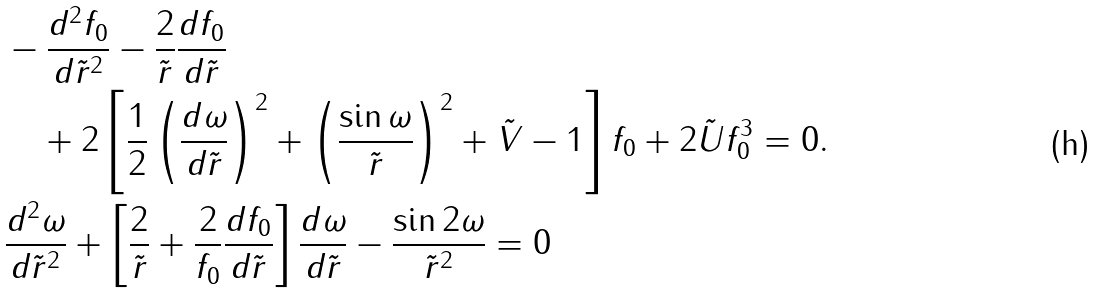<formula> <loc_0><loc_0><loc_500><loc_500>& - \frac { d ^ { 2 } f _ { 0 } } { d \tilde { r } ^ { 2 } } - \frac { 2 } { \tilde { r } } \frac { d f _ { 0 } } { d \tilde { r } } \\ & \quad + 2 \left [ \frac { 1 } { 2 } \left ( \frac { d \omega } { d \tilde { r } } \right ) ^ { 2 } + \left ( \frac { \sin \omega } { \tilde { r } } \right ) ^ { 2 } + \tilde { V } - 1 \right ] f _ { 0 } + 2 \tilde { U } f _ { 0 } ^ { 3 } = 0 . \\ & \frac { d ^ { 2 } \omega } { d \tilde { r } ^ { 2 } } + \left [ \frac { 2 } { \tilde { r } } + \frac { 2 } { f _ { 0 } } \frac { d f _ { 0 } } { d \tilde { r } } \right ] \frac { d \omega } { d \tilde { r } } - \frac { \sin { 2 \omega } } { \tilde { r } ^ { 2 } } = 0</formula> 